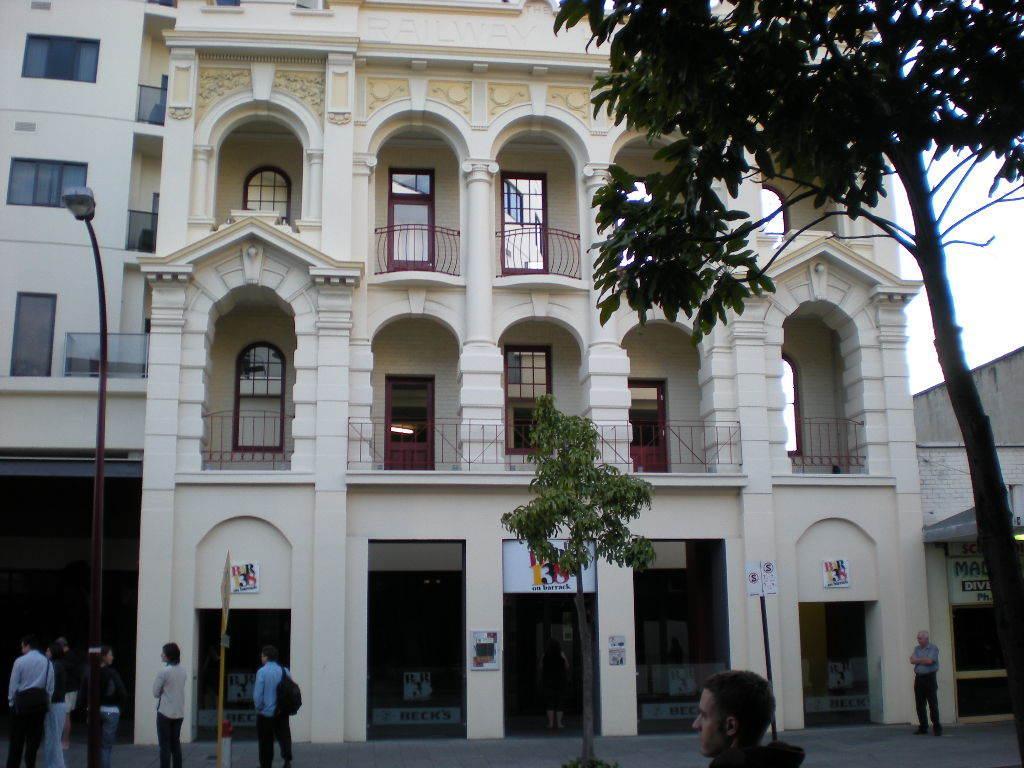Can you describe this image briefly? In this image there is a building, in front of the building there are a few people standing, there are trees and a street light. In the background there is the sky. 